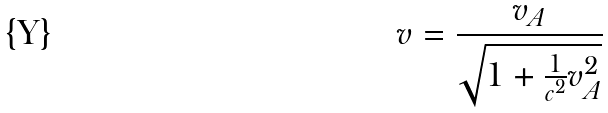Convert formula to latex. <formula><loc_0><loc_0><loc_500><loc_500>v = \frac { v _ { A } } { \sqrt { 1 + \frac { 1 } { c ^ { 2 } } v _ { A } ^ { 2 } } }</formula> 